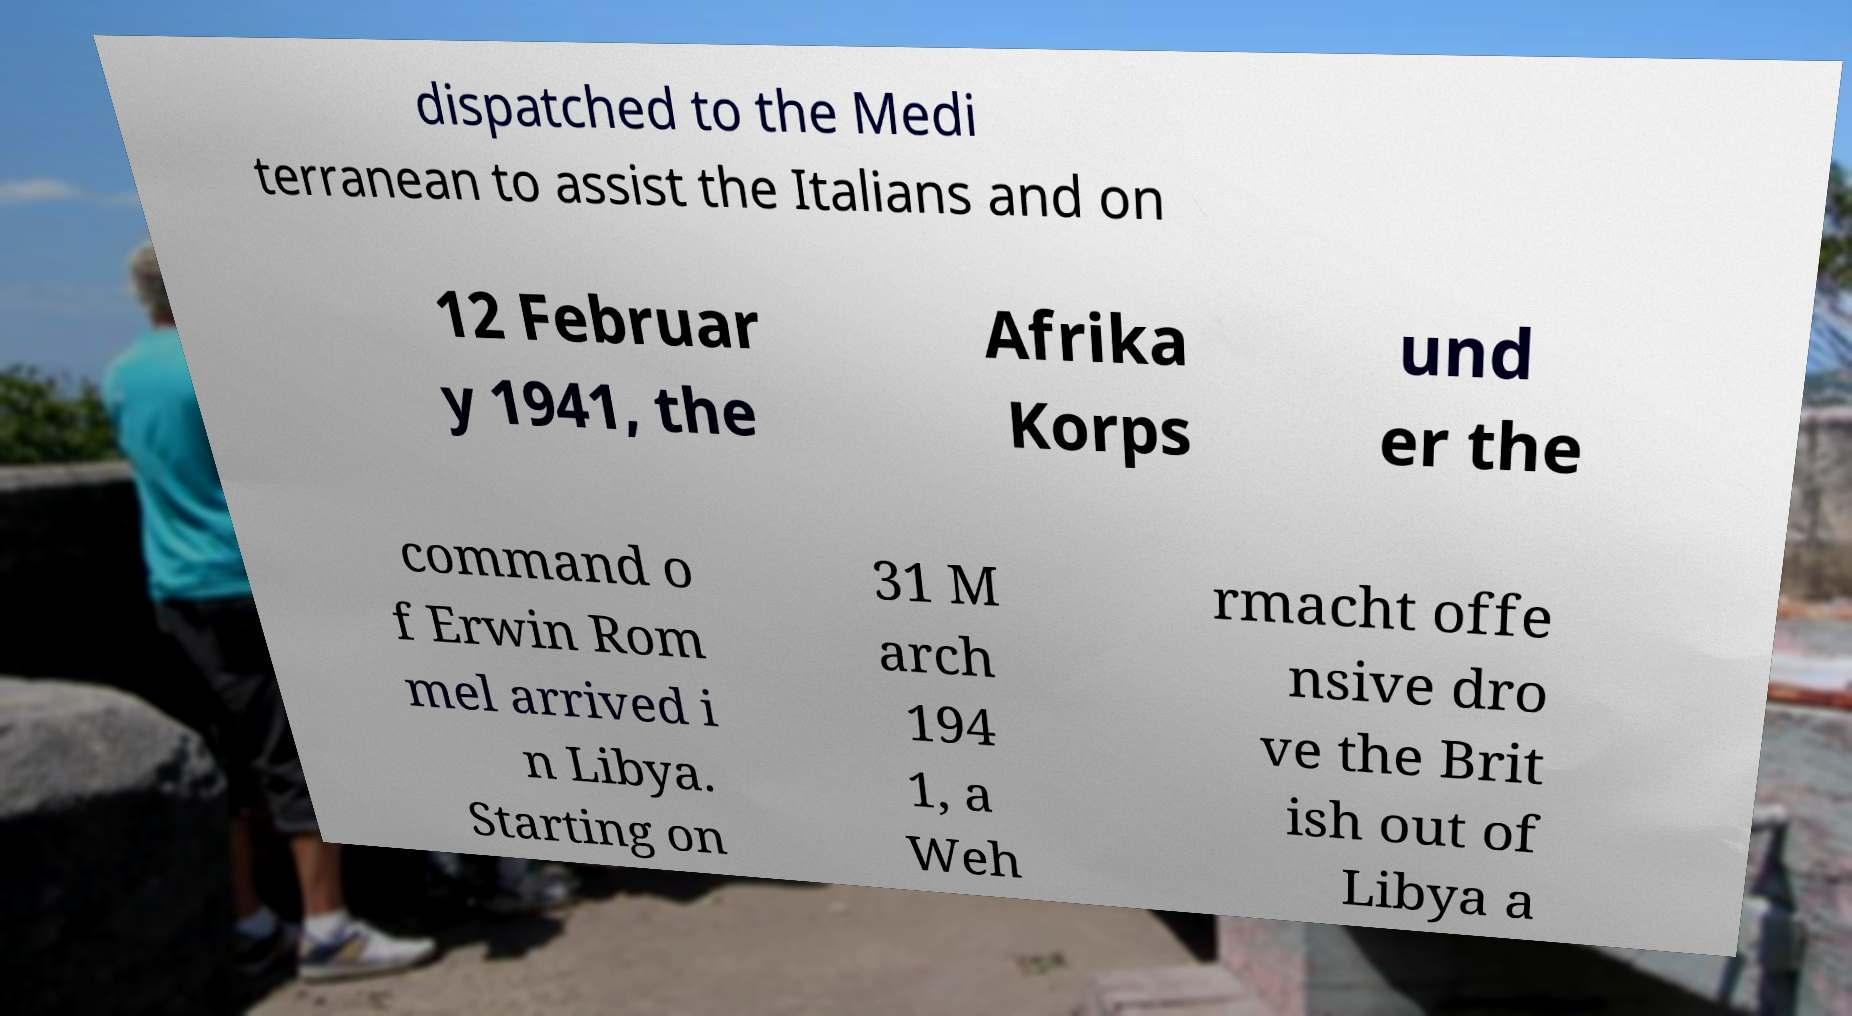There's text embedded in this image that I need extracted. Can you transcribe it verbatim? dispatched to the Medi terranean to assist the Italians and on 12 Februar y 1941, the Afrika Korps und er the command o f Erwin Rom mel arrived i n Libya. Starting on 31 M arch 194 1, a Weh rmacht offe nsive dro ve the Brit ish out of Libya a 